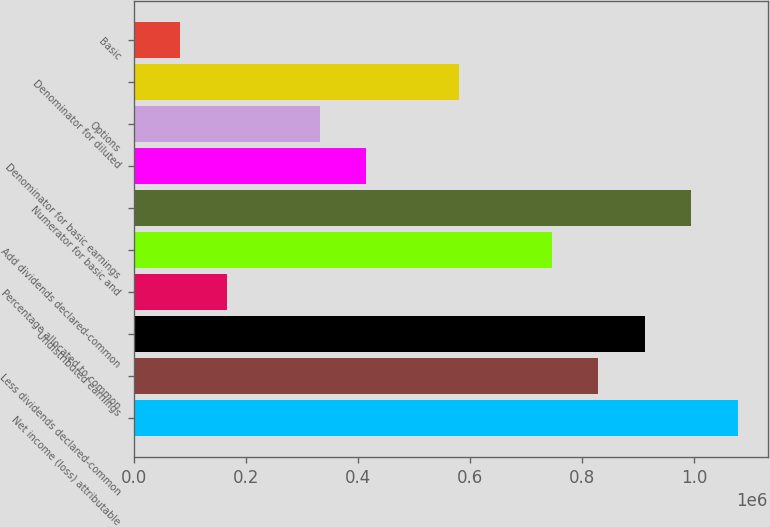<chart> <loc_0><loc_0><loc_500><loc_500><bar_chart><fcel>Net income (loss) attributable<fcel>Less dividends declared-common<fcel>Undistributed earnings<fcel>Percentage allocated to common<fcel>Add dividends declared-common<fcel>Numerator for basic and<fcel>Denominator for basic earnings<fcel>Options<fcel>Denominator for diluted<fcel>Basic<nl><fcel>1.07764e+06<fcel>828954<fcel>911848<fcel>165803<fcel>746060<fcel>994742<fcel>414485<fcel>331591<fcel>580273<fcel>82909.6<nl></chart> 